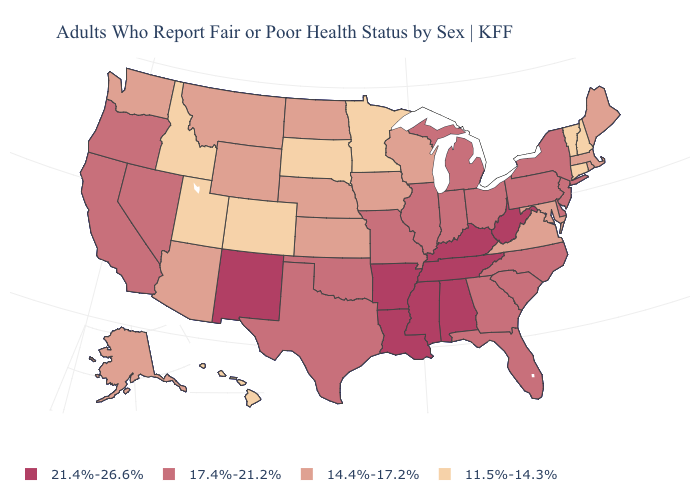Is the legend a continuous bar?
Keep it brief. No. What is the value of Illinois?
Concise answer only. 17.4%-21.2%. Does New York have the same value as Alabama?
Write a very short answer. No. Does the first symbol in the legend represent the smallest category?
Keep it brief. No. What is the highest value in states that border Indiana?
Answer briefly. 21.4%-26.6%. What is the highest value in the South ?
Concise answer only. 21.4%-26.6%. Among the states that border Utah , does Idaho have the highest value?
Write a very short answer. No. How many symbols are there in the legend?
Concise answer only. 4. What is the highest value in the USA?
Give a very brief answer. 21.4%-26.6%. Which states have the lowest value in the USA?
Answer briefly. Colorado, Connecticut, Hawaii, Idaho, Minnesota, New Hampshire, South Dakota, Utah, Vermont. Does the first symbol in the legend represent the smallest category?
Short answer required. No. Does Tennessee have the lowest value in the South?
Answer briefly. No. Does Florida have the highest value in the USA?
Concise answer only. No. What is the lowest value in the West?
Answer briefly. 11.5%-14.3%. Does Utah have the lowest value in the USA?
Short answer required. Yes. 